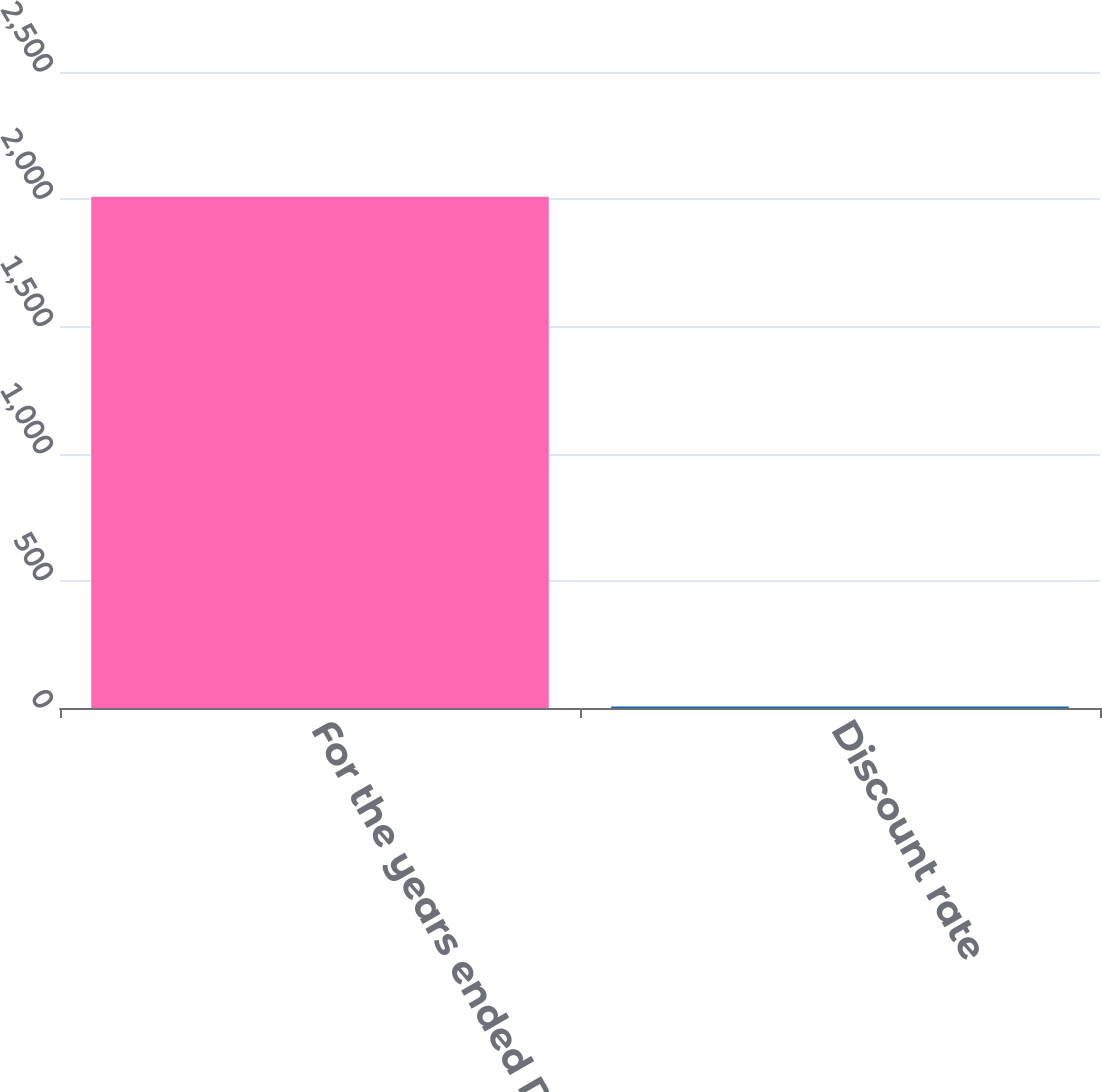Convert chart. <chart><loc_0><loc_0><loc_500><loc_500><bar_chart><fcel>For the years ended December<fcel>Discount rate<nl><fcel>2010<fcel>5.7<nl></chart> 